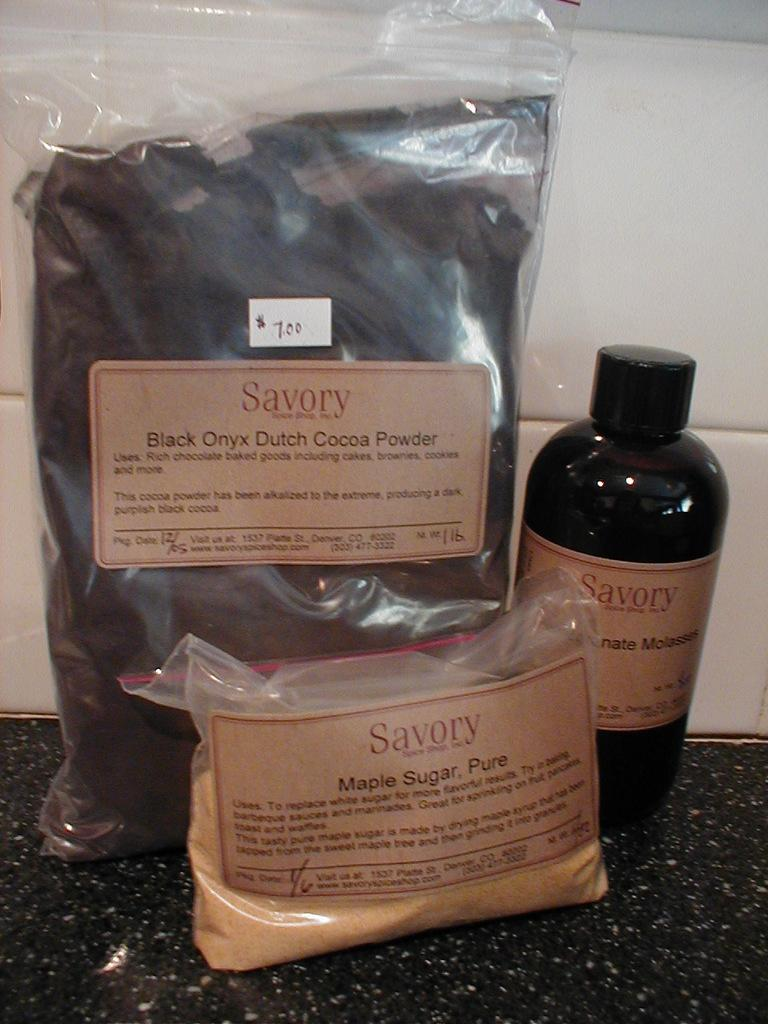Provide a one-sentence caption for the provided image. Savory brand items include Black Onyx Dutch Cocoa Powder, Pure Maple Sugar, and Molasses. 